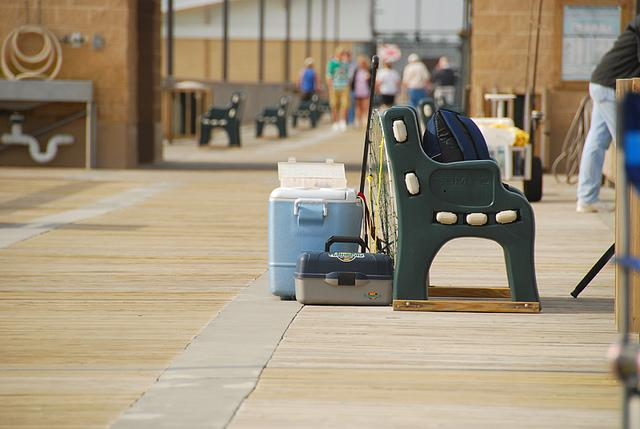What will the person who left this gear do with it?

Choices:
A) catch butterflies
B) go fishing
C) have picnic
D) water ski go fishing 